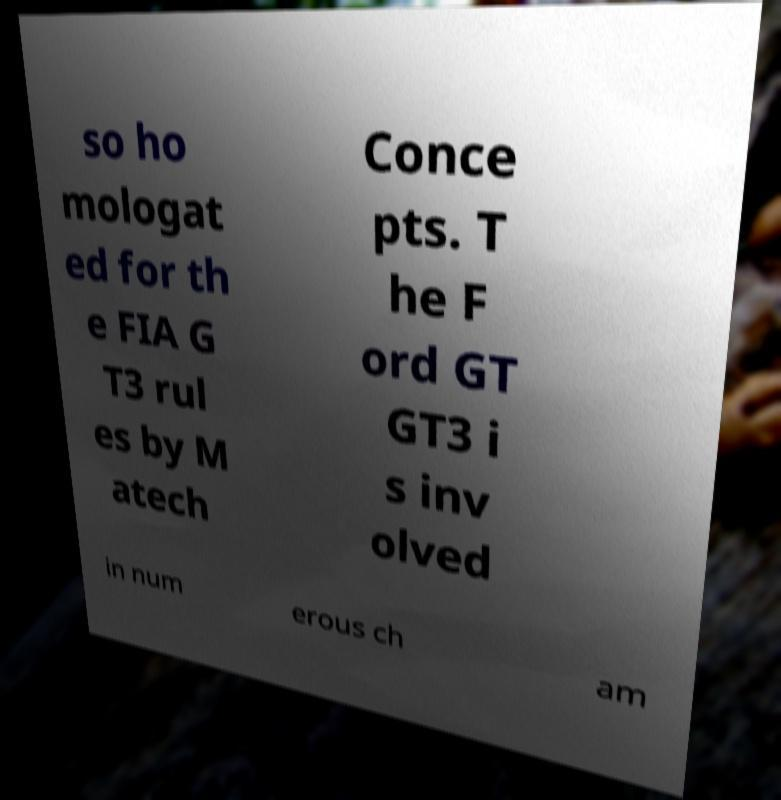For documentation purposes, I need the text within this image transcribed. Could you provide that? so ho mologat ed for th e FIA G T3 rul es by M atech Conce pts. T he F ord GT GT3 i s inv olved in num erous ch am 